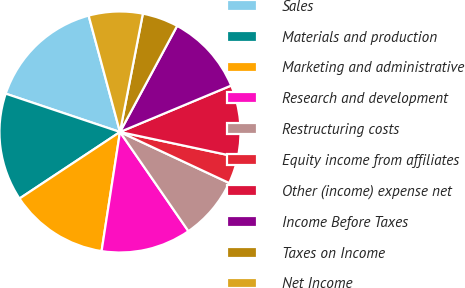<chart> <loc_0><loc_0><loc_500><loc_500><pie_chart><fcel>Sales<fcel>Materials and production<fcel>Marketing and administrative<fcel>Research and development<fcel>Restructuring costs<fcel>Equity income from affiliates<fcel>Other (income) expense net<fcel>Income Before Taxes<fcel>Taxes on Income<fcel>Net Income<nl><fcel>15.66%<fcel>14.46%<fcel>13.25%<fcel>12.05%<fcel>8.43%<fcel>3.61%<fcel>9.64%<fcel>10.84%<fcel>4.82%<fcel>7.23%<nl></chart> 